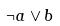<formula> <loc_0><loc_0><loc_500><loc_500>\neg a \vee b</formula> 